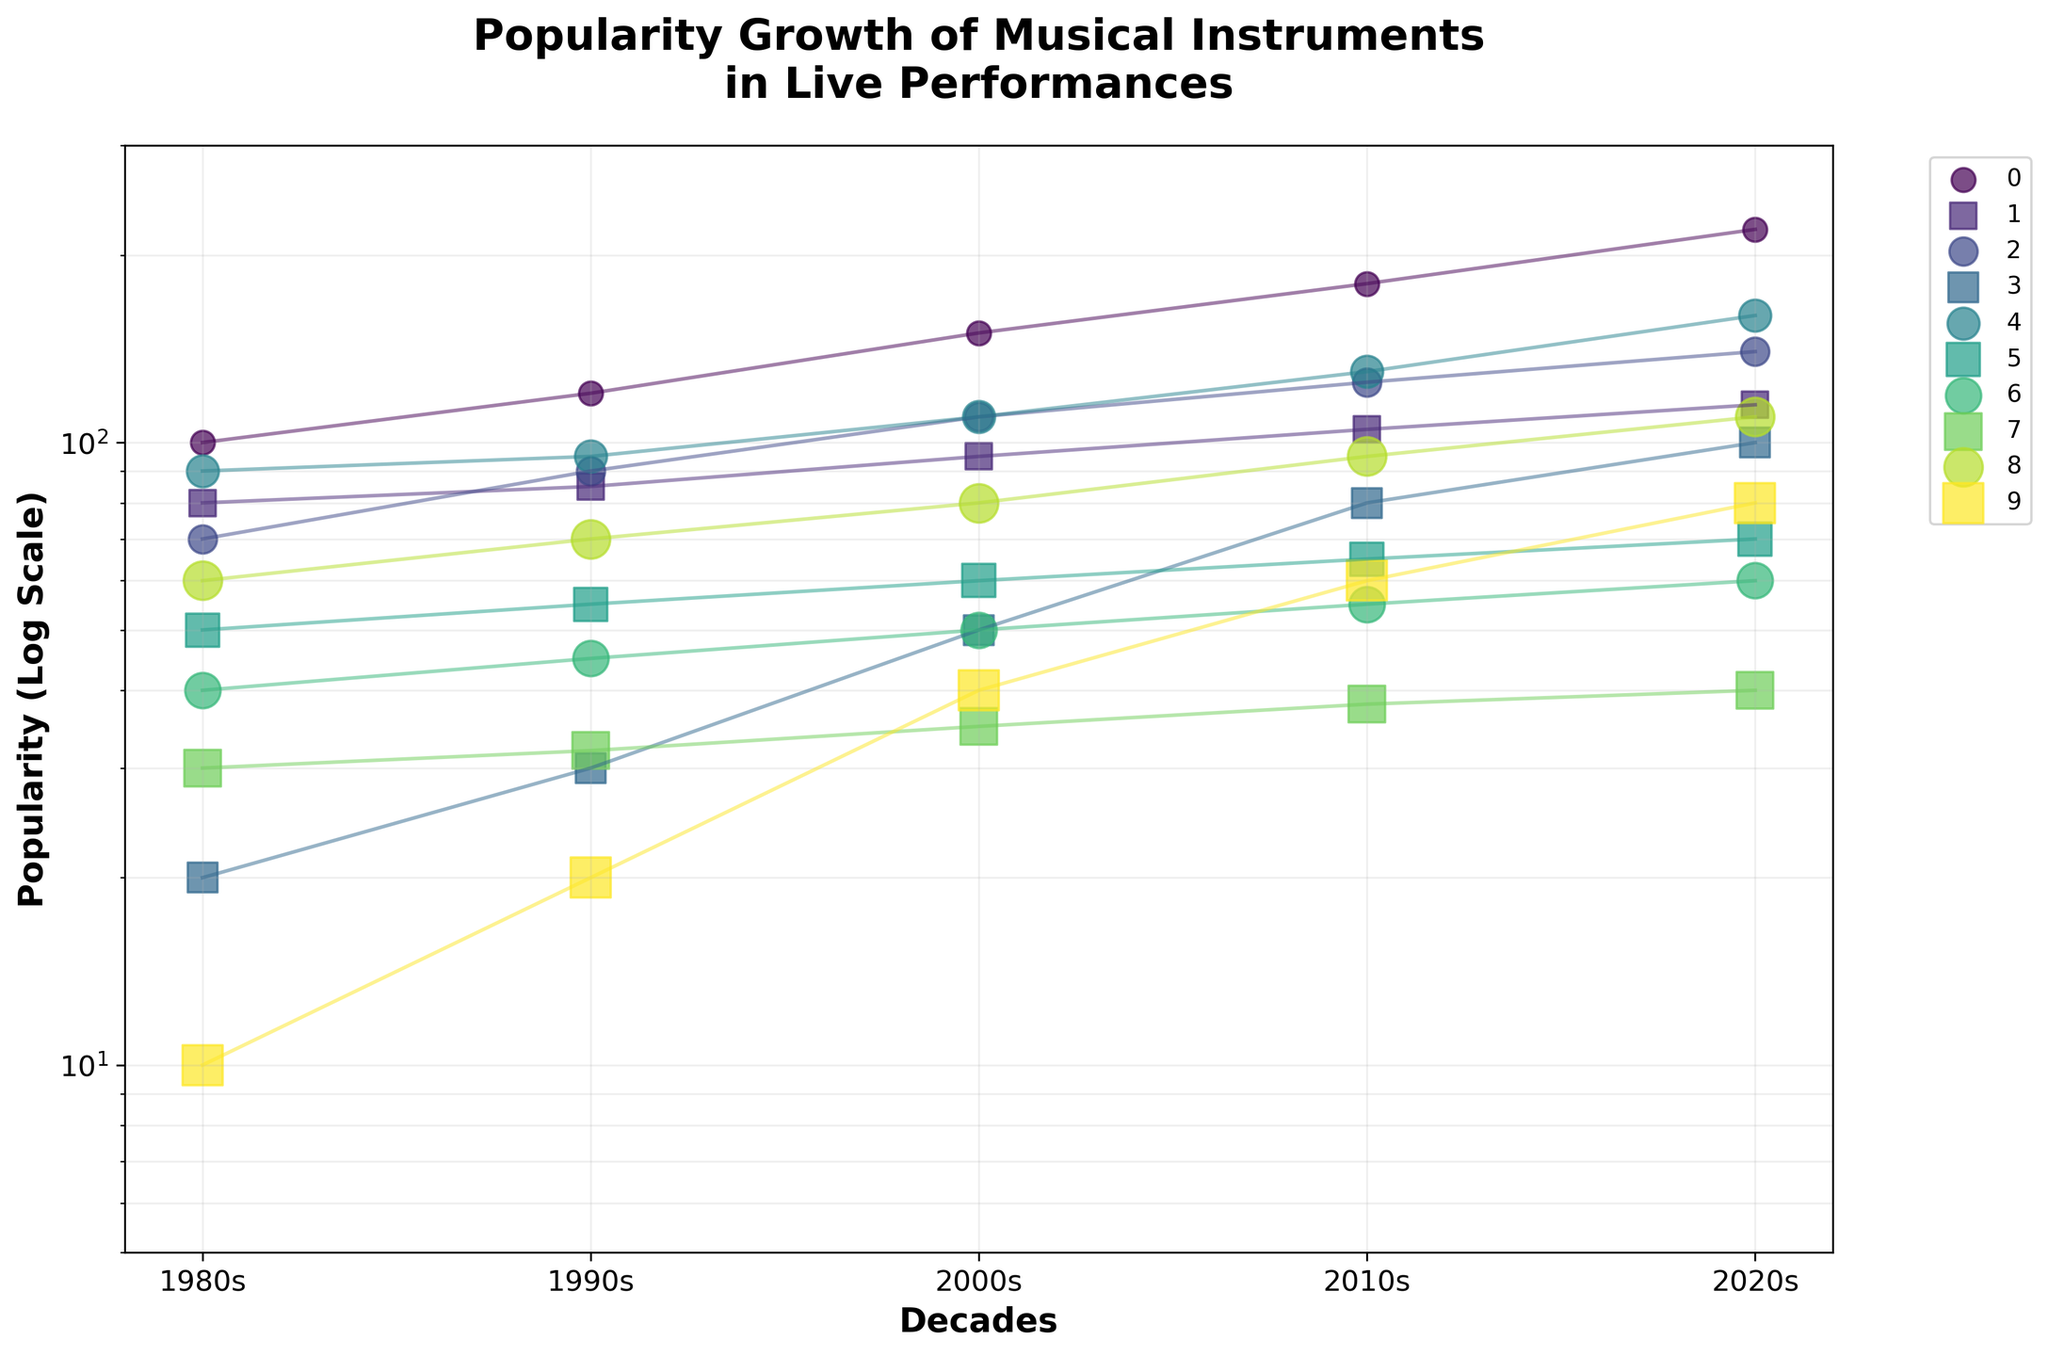What's the title of the figure? The title is prominently displayed at the top of the figure. It reads "Popularity Growth of Musical Instruments in Live Performances".
Answer: Popularity Growth of Musical Instruments in Live Performances Which musical instrument had the highest popularity in the 2020s? The electric guitar's data point for the 2020s is the highest in the 2020s column, indicating it had the highest popularity.
Answer: Electric Guitar How did the popularity of the drum kit change from the 1980s to the 2020s? The popularity of the drum kit increased from 90 in the 1980s to 160 in the 2020s, as seen from the data points connected by the line for the drum kit.
Answer: Increased from 90 to 160 What trend do we see in the popularity of the synthesizer over the decades? The synthesizer's data points show a consistent upward trend, starting from 20 in the 1980s and increasing to 100 in the 2020s.
Answer: Consistent increase Which two instruments had almost overlapping popularity in 2000s? The piano and drum kit have data points that are very close in the 2000s, both around 110.
Answer: Piano and Drum Kit Compare the popularity growth rates of the digital sampler and the saxophone from the 1980s to the 2020s. The digital sampler's popularity increased from 10 to 80, whereas the saxophone's popularity only increased from 50 to 70. This shows the digital sampler had a significantly higher growth rate compared to the saxophone.
Answer: Digital sampler had a higher growth rate What is the range of popularity values shown on the y-axis? The y-axis ranges from 5 to 300, as indicated by the scale and axis labels.
Answer: 5 to 300 Between the violin and trumpet, which instrument showed higher popularity in the 1990s? The data point for the violin in the 1990s is 45, which is higher than the trumpet's value of 32 in the same decade.
Answer: Violin Calculate the average popularity of the acoustic guitar over the decades. Summing the popularity values of the acoustic guitar (80, 85, 95, 105, 115) gives 480. Dividing by the number of decades (5), the average is 480 / 5 = 96.
Answer: 96 How does the log scale affect the visualization of the data? A log scale spreads out the smaller values and compresses the larger values, making it easier to see trends and relative differences among smaller and larger numbers. This is particularly useful in our figure since the popularity values range widely.
Answer: Spreads out smaller values, compresses larger values 